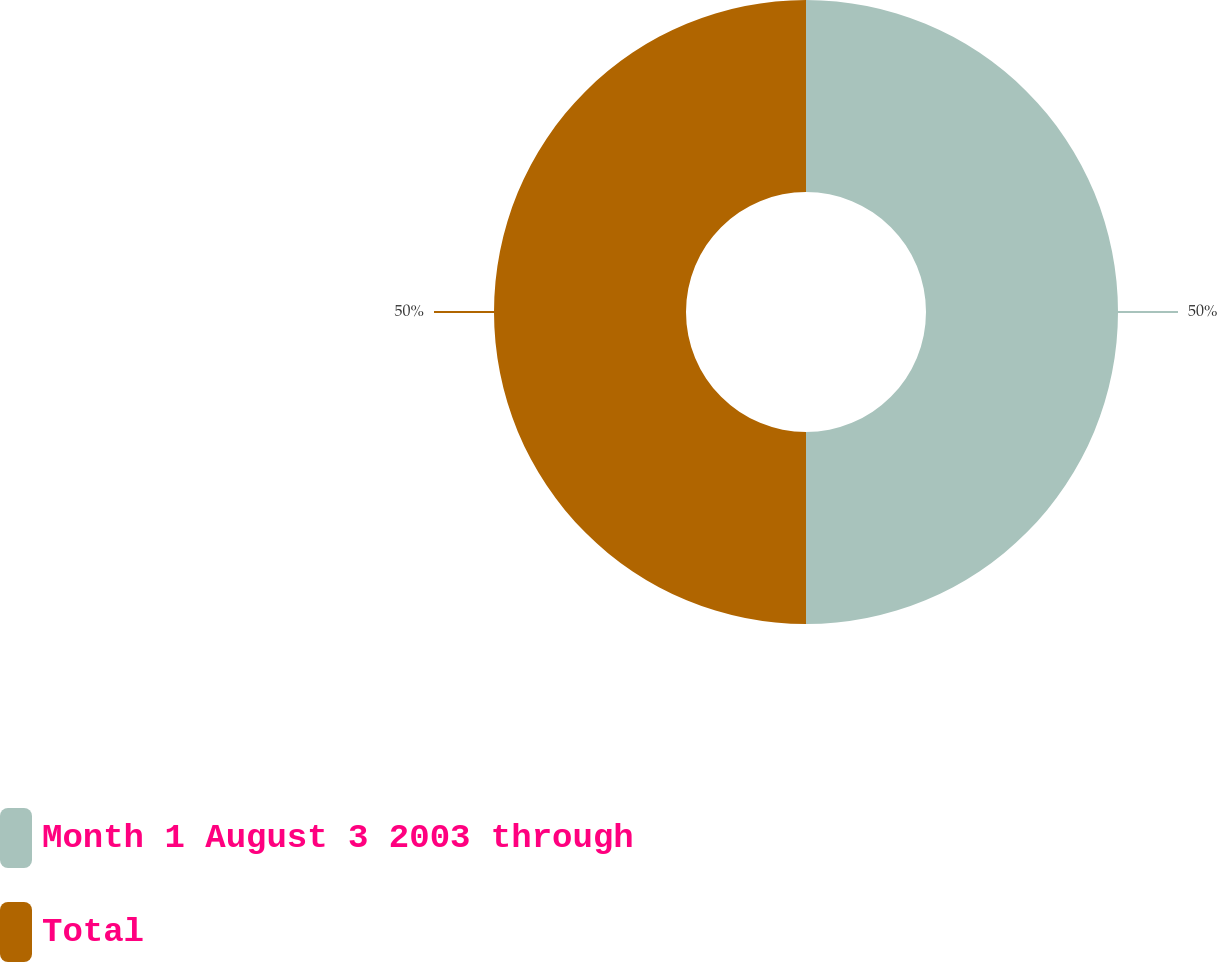Convert chart. <chart><loc_0><loc_0><loc_500><loc_500><pie_chart><fcel>Month 1 August 3 2003 through<fcel>Total<nl><fcel>50.0%<fcel>50.0%<nl></chart> 